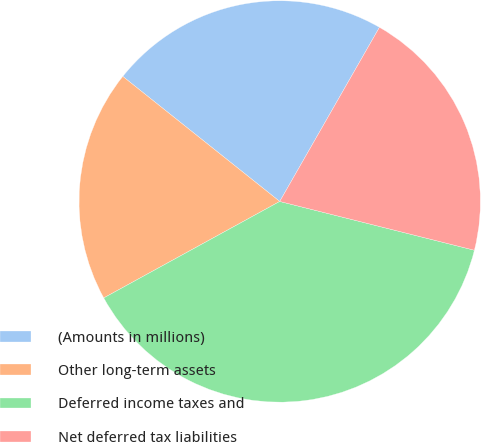Convert chart to OTSL. <chart><loc_0><loc_0><loc_500><loc_500><pie_chart><fcel>(Amounts in millions)<fcel>Other long-term assets<fcel>Deferred income taxes and<fcel>Net deferred tax liabilities<nl><fcel>22.57%<fcel>18.69%<fcel>38.11%<fcel>20.63%<nl></chart> 